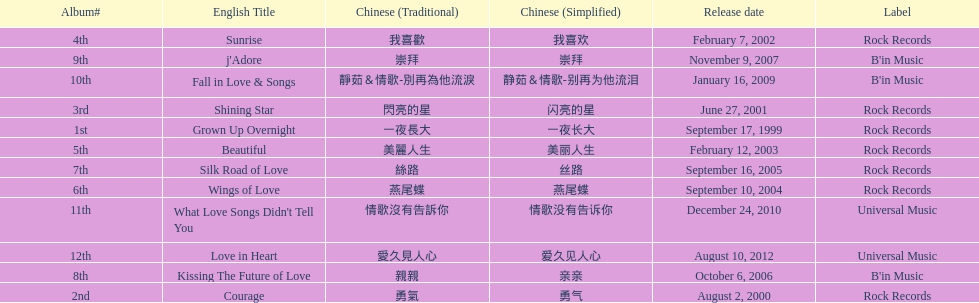What songs were on b'in music or universal music? Kissing The Future of Love, j'Adore, Fall in Love & Songs, What Love Songs Didn't Tell You, Love in Heart. 